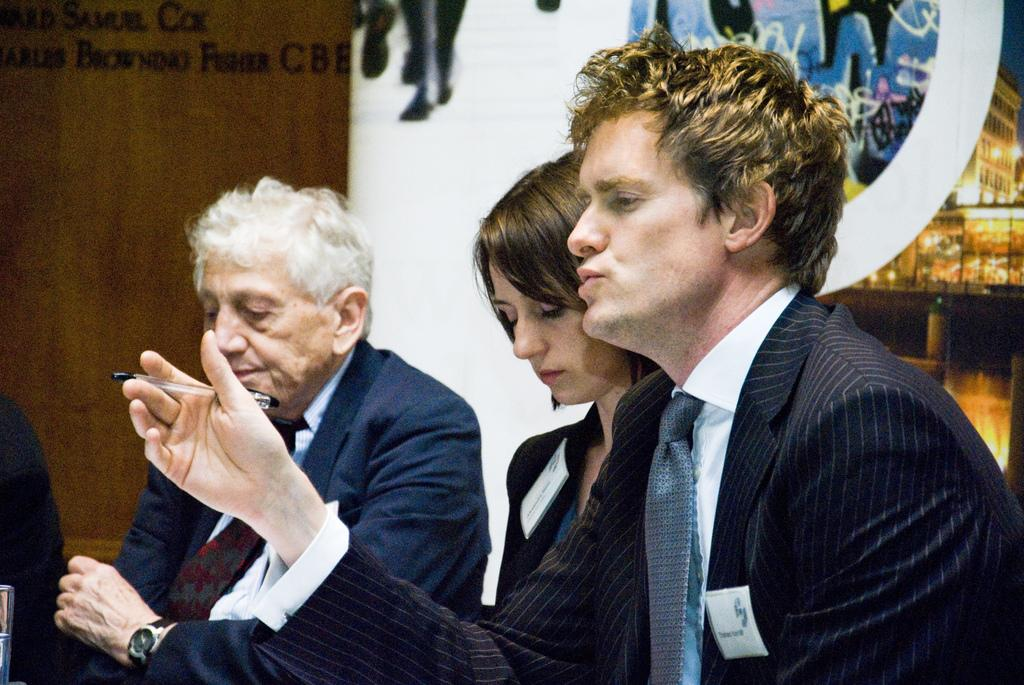How many people are in the image? There are three persons in the image. Can you describe the gender of each person? One of them is a woman, and two of them are men. What are the people wearing in the image? All three persons are wearing blazers. Can you identify any specific object held by one of the men? One of the men is holding a pen. What type of wine is being served by the coach in the image? There is no coach or wine present in the image. How many keys can be seen in the hands of the woman in the image? There are no keys visible in the image; the woman is not holding any keys. 